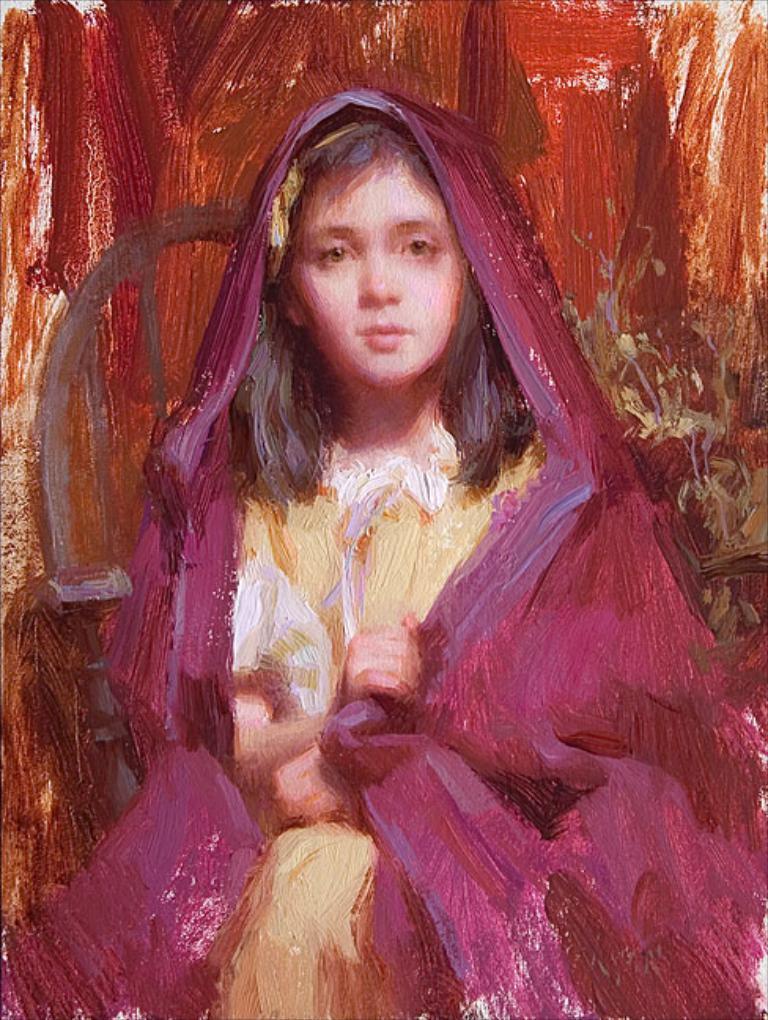How would you summarize this image in a sentence or two? In this image we can see there is a painting of sitting girl. 